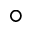Convert formula to latex. <formula><loc_0><loc_0><loc_500><loc_500>^ { \circ }</formula> 